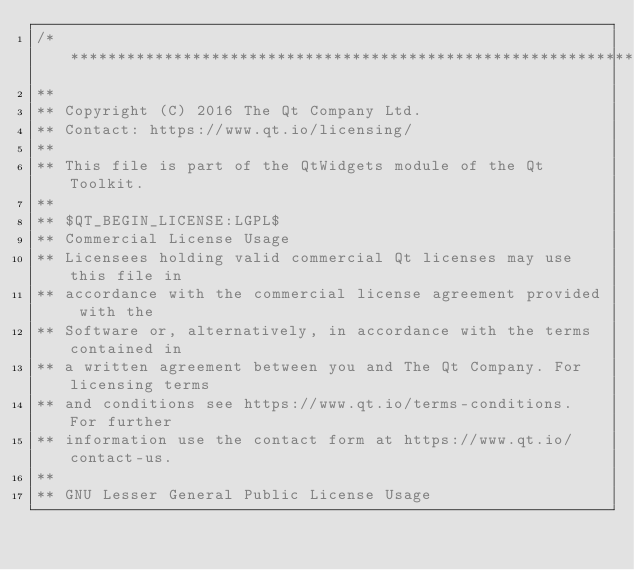<code> <loc_0><loc_0><loc_500><loc_500><_C++_>/****************************************************************************
**
** Copyright (C) 2016 The Qt Company Ltd.
** Contact: https://www.qt.io/licensing/
**
** This file is part of the QtWidgets module of the Qt Toolkit.
**
** $QT_BEGIN_LICENSE:LGPL$
** Commercial License Usage
** Licensees holding valid commercial Qt licenses may use this file in
** accordance with the commercial license agreement provided with the
** Software or, alternatively, in accordance with the terms contained in
** a written agreement between you and The Qt Company. For licensing terms
** and conditions see https://www.qt.io/terms-conditions. For further
** information use the contact form at https://www.qt.io/contact-us.
**
** GNU Lesser General Public License Usage</code> 